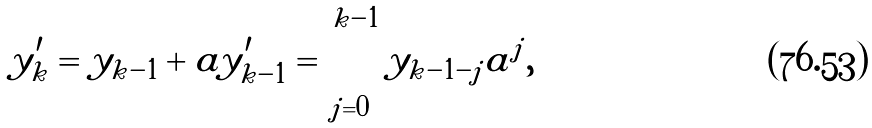<formula> <loc_0><loc_0><loc_500><loc_500>y _ { k } ^ { \prime } = y _ { k - 1 } + a y _ { k - 1 } ^ { \prime } = \sum _ { j = 0 } ^ { k - 1 } y _ { k - 1 - j } a ^ { j } ,</formula> 